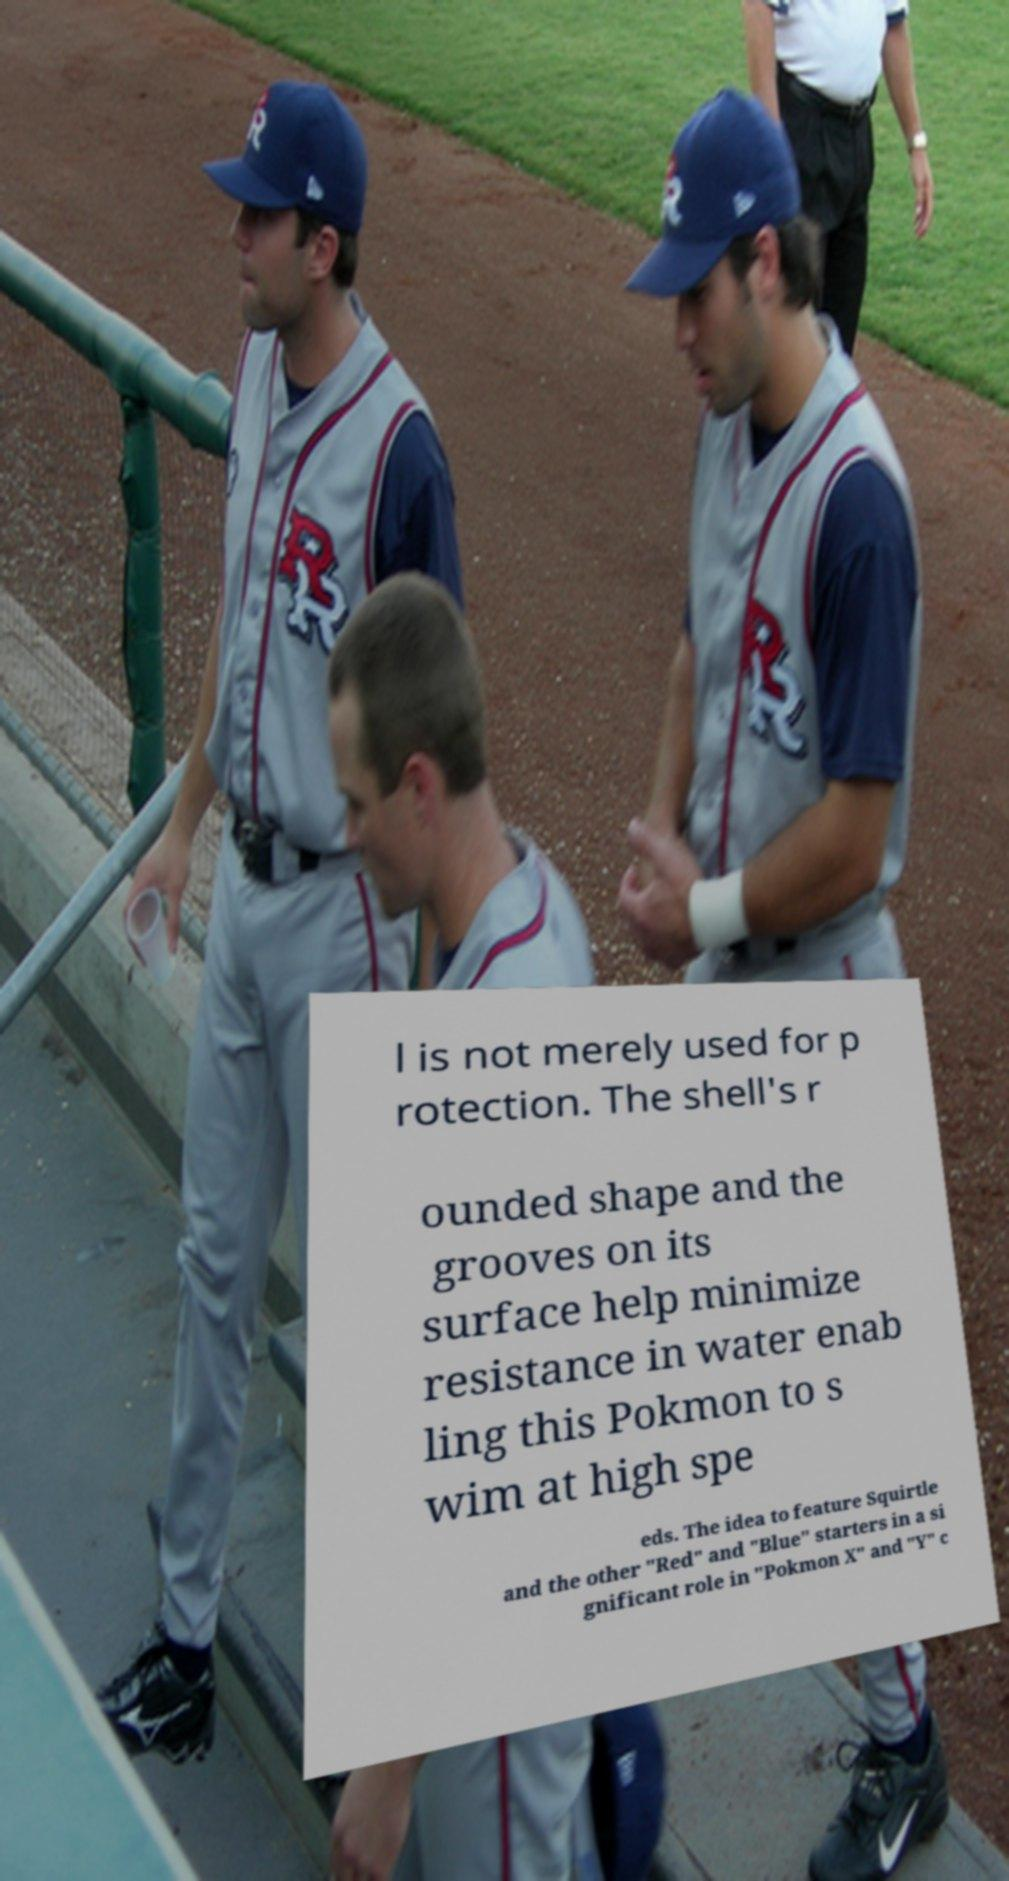For documentation purposes, I need the text within this image transcribed. Could you provide that? l is not merely used for p rotection. The shell's r ounded shape and the grooves on its surface help minimize resistance in water enab ling this Pokmon to s wim at high spe eds. The idea to feature Squirtle and the other "Red" and "Blue" starters in a si gnificant role in "Pokmon X" and "Y" c 